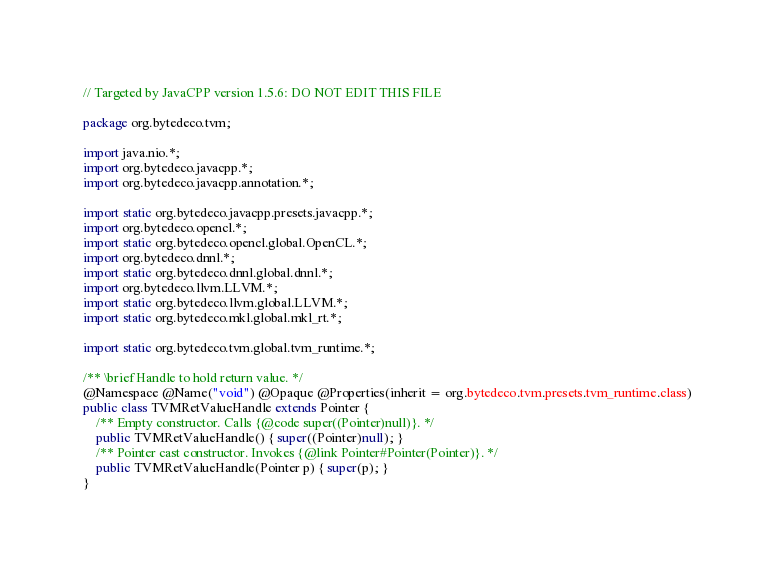Convert code to text. <code><loc_0><loc_0><loc_500><loc_500><_Java_>// Targeted by JavaCPP version 1.5.6: DO NOT EDIT THIS FILE

package org.bytedeco.tvm;

import java.nio.*;
import org.bytedeco.javacpp.*;
import org.bytedeco.javacpp.annotation.*;

import static org.bytedeco.javacpp.presets.javacpp.*;
import org.bytedeco.opencl.*;
import static org.bytedeco.opencl.global.OpenCL.*;
import org.bytedeco.dnnl.*;
import static org.bytedeco.dnnl.global.dnnl.*;
import org.bytedeco.llvm.LLVM.*;
import static org.bytedeco.llvm.global.LLVM.*;
import static org.bytedeco.mkl.global.mkl_rt.*;

import static org.bytedeco.tvm.global.tvm_runtime.*;

/** \brief Handle to hold return value. */
@Namespace @Name("void") @Opaque @Properties(inherit = org.bytedeco.tvm.presets.tvm_runtime.class)
public class TVMRetValueHandle extends Pointer {
    /** Empty constructor. Calls {@code super((Pointer)null)}. */
    public TVMRetValueHandle() { super((Pointer)null); }
    /** Pointer cast constructor. Invokes {@link Pointer#Pointer(Pointer)}. */
    public TVMRetValueHandle(Pointer p) { super(p); }
}
</code> 